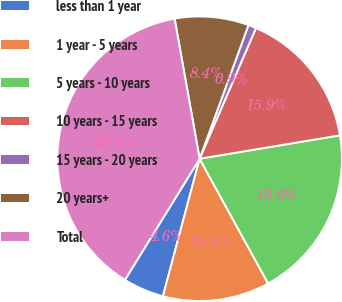<chart> <loc_0><loc_0><loc_500><loc_500><pie_chart><fcel>less than 1 year<fcel>1 year - 5 years<fcel>5 years - 10 years<fcel>10 years - 15 years<fcel>15 years - 20 years<fcel>20 years+<fcel>Total<nl><fcel>4.64%<fcel>12.14%<fcel>19.64%<fcel>15.89%<fcel>0.9%<fcel>8.39%<fcel>38.39%<nl></chart> 